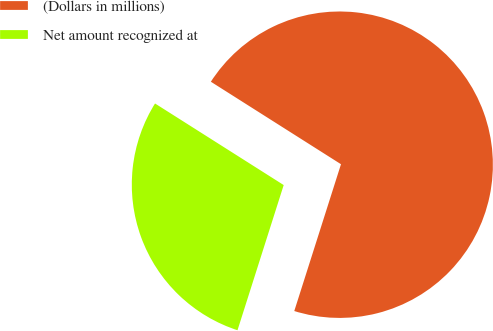Convert chart to OTSL. <chart><loc_0><loc_0><loc_500><loc_500><pie_chart><fcel>(Dollars in millions)<fcel>Net amount recognized at<nl><fcel>70.91%<fcel>29.09%<nl></chart> 